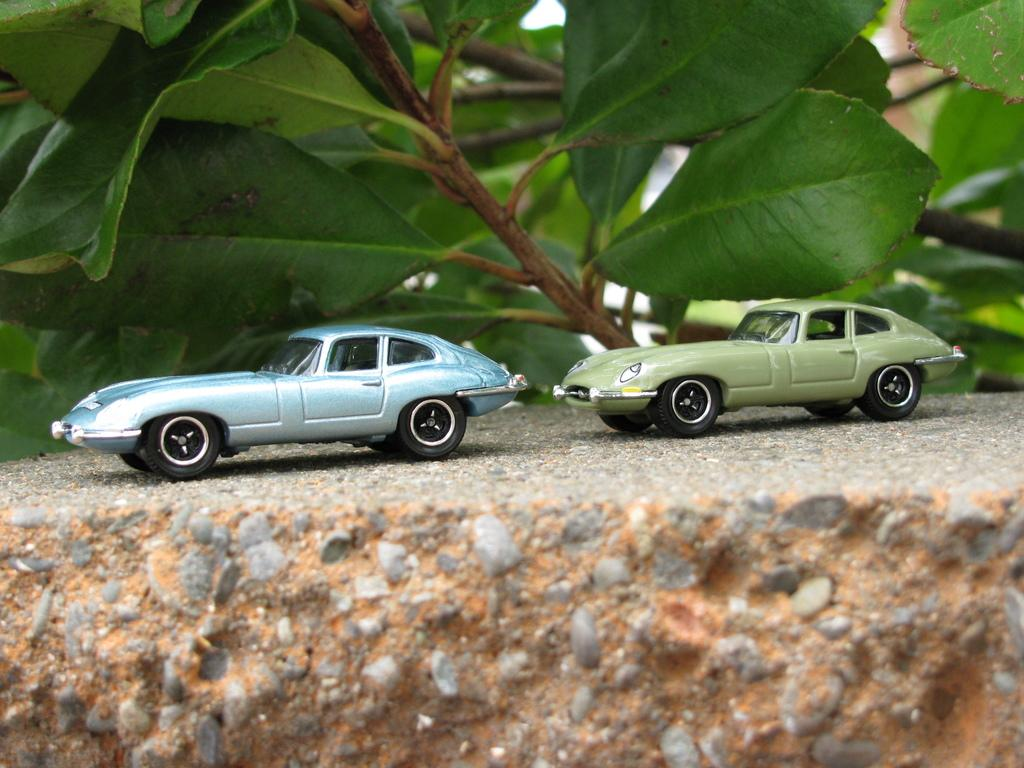How many toy cars are visible in the image? There are two toy cars in the image. Where is the first toy car located? One toy car is on the left side. Where is the second toy car located? One toy car is on the right side. What else can be seen in the image besides the toy cars? There are plants in the image. What direction is the mailbox facing in the image? There is no mailbox present in the image. How many plants are in the cellar in the image? There is no cellar present in the image. 